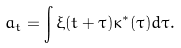<formula> <loc_0><loc_0><loc_500><loc_500>a _ { t } = \int \xi ( t + \tau ) \kappa ^ { \ast } ( \tau ) d \tau .</formula> 